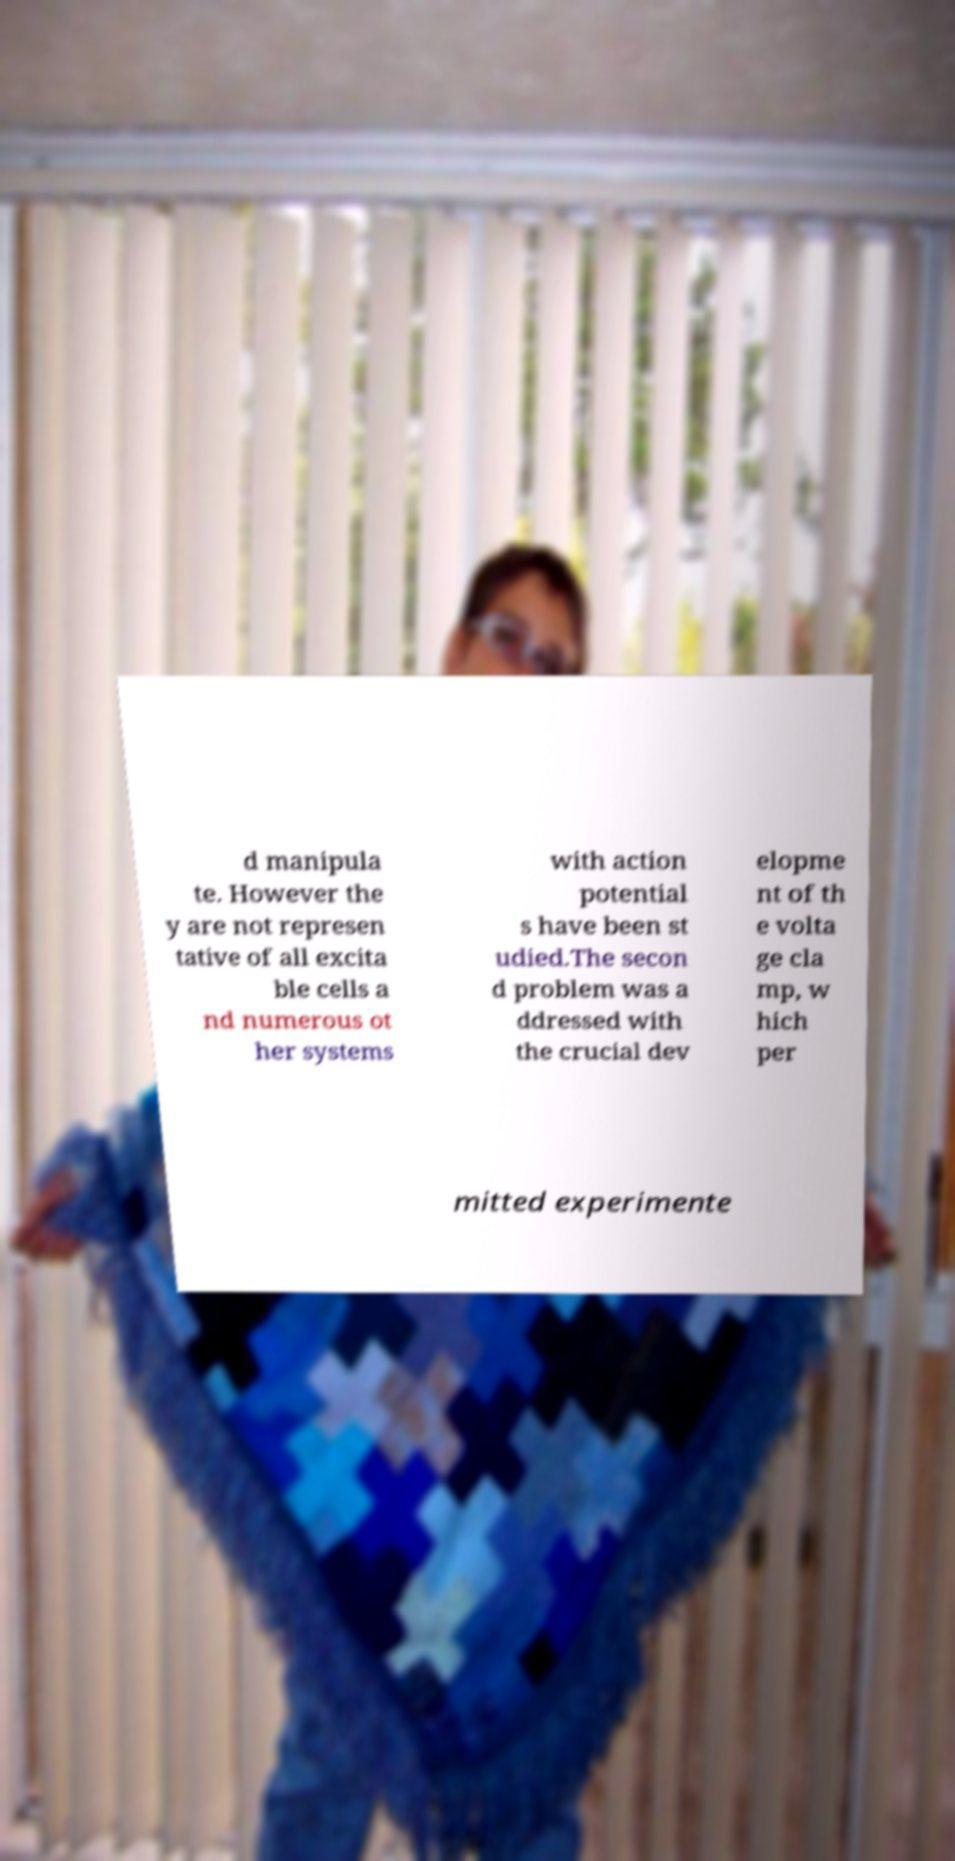What messages or text are displayed in this image? I need them in a readable, typed format. d manipula te. However the y are not represen tative of all excita ble cells a nd numerous ot her systems with action potential s have been st udied.The secon d problem was a ddressed with the crucial dev elopme nt of th e volta ge cla mp, w hich per mitted experimente 